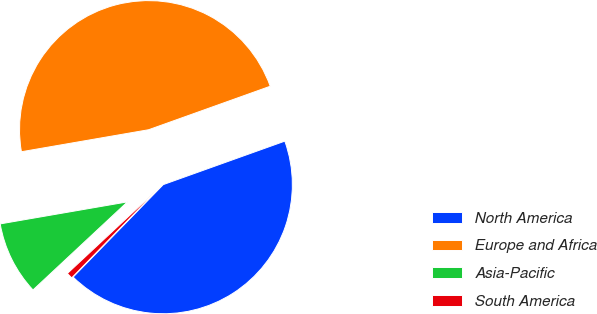Convert chart to OTSL. <chart><loc_0><loc_0><loc_500><loc_500><pie_chart><fcel>North America<fcel>Europe and Africa<fcel>Asia-Pacific<fcel>South America<nl><fcel>42.76%<fcel>47.26%<fcel>9.22%<fcel>0.76%<nl></chart> 